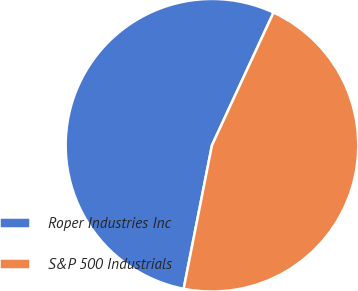Convert chart. <chart><loc_0><loc_0><loc_500><loc_500><pie_chart><fcel>Roper Industries Inc<fcel>S&P 500 Industrials<nl><fcel>53.81%<fcel>46.19%<nl></chart> 